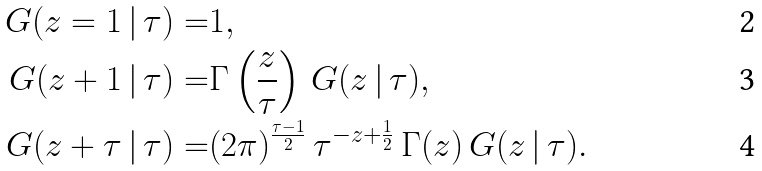Convert formula to latex. <formula><loc_0><loc_0><loc_500><loc_500>G ( z = 1 \, | \, \tau ) = & 1 , \\ G ( z + 1 \, | \, \tau ) = & \Gamma \left ( \frac { z } { \tau } \right ) \, G ( z \, | \, \tau ) , \\ G ( z + \tau \, | \, \tau ) = & ( 2 \pi ) ^ { \frac { \tau - 1 } { 2 } } \, \tau ^ { - z + \frac { 1 } { 2 } } \, \Gamma ( z ) \, G ( z \, | \, \tau ) .</formula> 